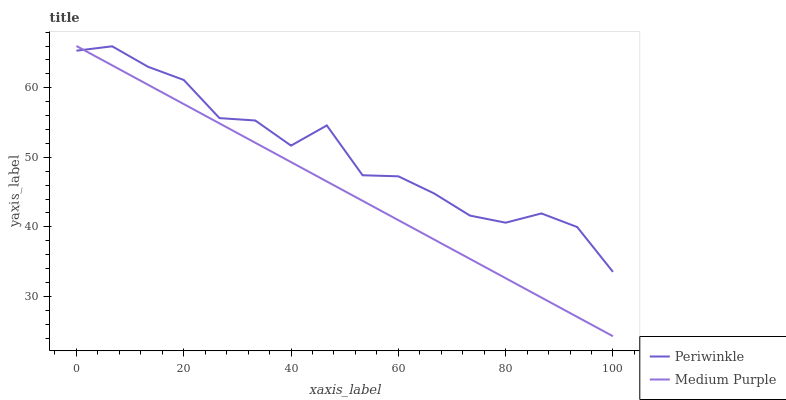Does Medium Purple have the minimum area under the curve?
Answer yes or no. Yes. Does Periwinkle have the maximum area under the curve?
Answer yes or no. Yes. Does Periwinkle have the minimum area under the curve?
Answer yes or no. No. Is Medium Purple the smoothest?
Answer yes or no. Yes. Is Periwinkle the roughest?
Answer yes or no. Yes. Is Periwinkle the smoothest?
Answer yes or no. No. Does Periwinkle have the lowest value?
Answer yes or no. No. Does Medium Purple have the highest value?
Answer yes or no. Yes. Does Periwinkle have the highest value?
Answer yes or no. No. 